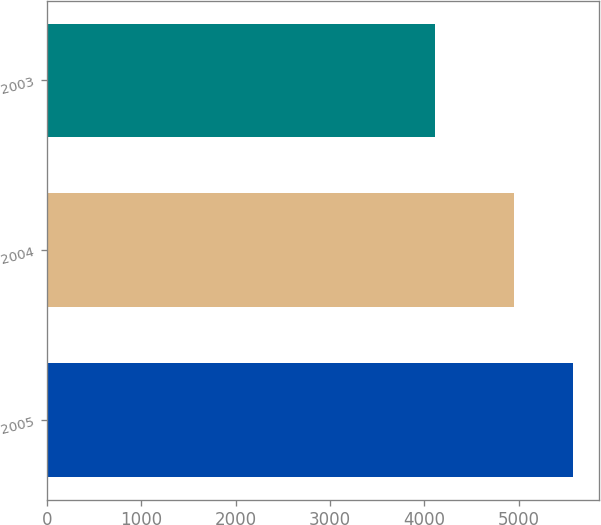Convert chart. <chart><loc_0><loc_0><loc_500><loc_500><bar_chart><fcel>2005<fcel>2004<fcel>2003<nl><fcel>5575<fcel>4950<fcel>4113<nl></chart> 